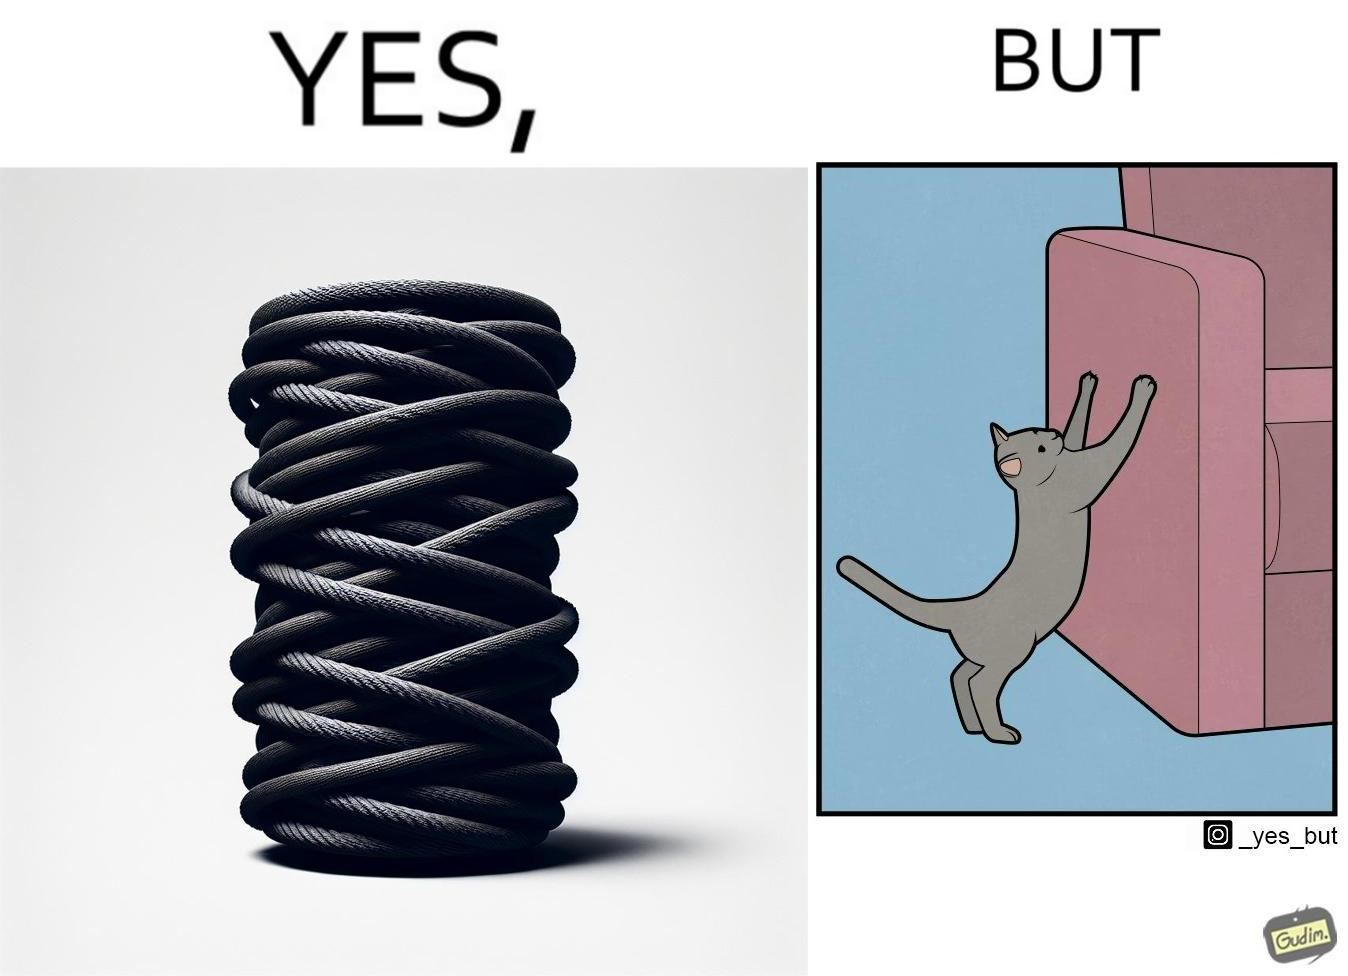Provide a description of this image. The image is ironic, because in the first image a toy, purposed for the cat to play with is shown but in the second image the cat is comfortably enjoying  to play on the sides of sofa 